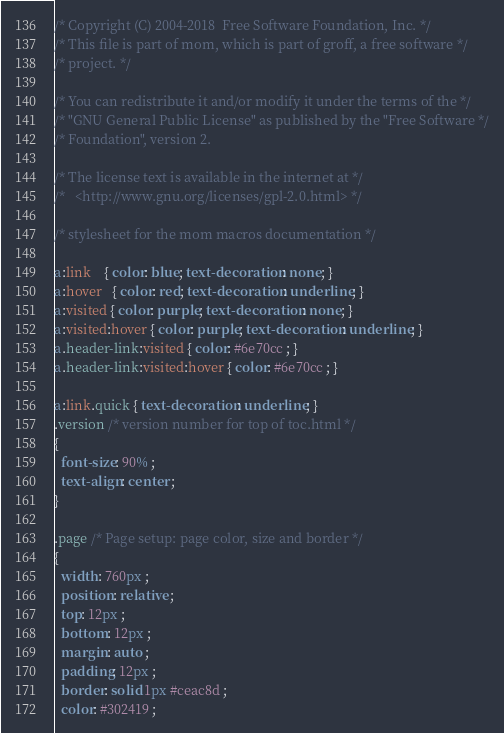<code> <loc_0><loc_0><loc_500><loc_500><_CSS_>/* Copyright (C) 2004-2018  Free Software Foundation, Inc. */
/* This file is part of mom, which is part of groff, a free software */
/* project. */

/* You can redistribute it and/or modify it under the terms of the */
/* "GNU General Public License" as published by the "Free Software */
/* Foundation", version 2.

/* The license text is available in the internet at */
/*   <http://www.gnu.org/licenses/gpl-2.0.html> */

/* stylesheet for the mom macros documentation */

a:link    { color: blue; text-decoration: none; }
a:hover   { color: red; text-decoration: underline; }
a:visited { color: purple; text-decoration: none; }
a:visited:hover { color: purple; text-decoration: underline; }
a.header-link:visited { color: #6e70cc ; }
a.header-link:visited:hover { color: #6e70cc ; }

a:link.quick { text-decoration: underline; }
.version /* version number for top of toc.html */
{
  font-size: 90% ;
  text-align: center ;
}

.page /* Page setup: page color, size and border */
{
  width: 760px ;
  position: relative ;
  top: 12px ;
  bottom: 12px ;
  margin: auto ;
  padding: 12px ; 
  border: solid 1px #ceac8d ;
  color: #302419 ;</code> 